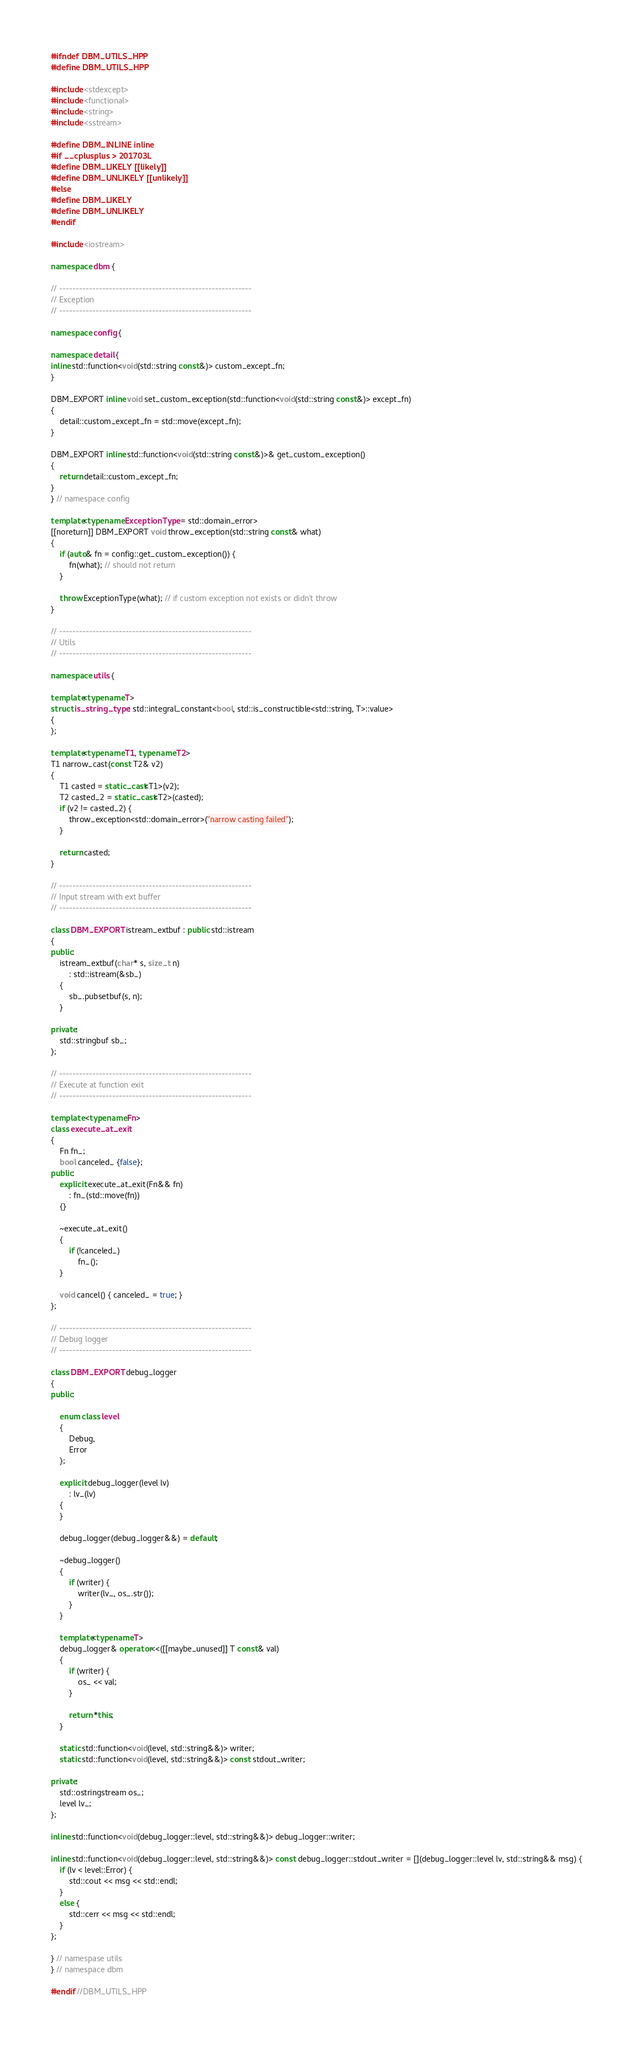<code> <loc_0><loc_0><loc_500><loc_500><_C++_>#ifndef DBM_UTILS_HPP
#define DBM_UTILS_HPP

#include <stdexcept>
#include <functional>
#include <string>
#include <sstream>

#define DBM_INLINE inline
#if __cplusplus > 201703L
#define DBM_LIKELY [[likely]]
#define DBM_UNLIKELY [[unlikely]]
#else
#define DBM_LIKELY
#define DBM_UNLIKELY
#endif

#include <iostream>

namespace dbm {

// ----------------------------------------------------------
// Exception
// ----------------------------------------------------------

namespace config {

namespace detail {
inline std::function<void(std::string const&)> custom_except_fn;
}

DBM_EXPORT inline void set_custom_exception(std::function<void(std::string const&)> except_fn)
{
    detail::custom_except_fn = std::move(except_fn);
}

DBM_EXPORT inline std::function<void(std::string const&)>& get_custom_exception()
{
    return detail::custom_except_fn;
}
} // namespace config

template<typename ExceptionType = std::domain_error>
[[noreturn]] DBM_EXPORT void throw_exception(std::string const& what)
{
    if (auto& fn = config::get_custom_exception()) {
        fn(what); // should not return
    }

    throw ExceptionType(what); // if custom exception not exists or didn't throw
}

// ----------------------------------------------------------
// Utils
// ----------------------------------------------------------

namespace utils {

template<typename T>
struct is_string_type : std::integral_constant<bool, std::is_constructible<std::string, T>::value>
{
};

template<typename T1, typename T2>
T1 narrow_cast(const T2& v2)
{
    T1 casted = static_cast<T1>(v2);
    T2 casted_2 = static_cast<T2>(casted);
    if (v2 != casted_2) {
        throw_exception<std::domain_error>("narrow casting failed");
    }

    return casted;
}

// ----------------------------------------------------------
// Input stream with ext buffer
// ----------------------------------------------------------

class DBM_EXPORT istream_extbuf : public std::istream
{
public:
    istream_extbuf(char* s, size_t n)
        : std::istream(&sb_)
    {
        sb_.pubsetbuf(s, n);
    }

private:
    std::stringbuf sb_;
};

// ----------------------------------------------------------
// Execute at function exit
// ----------------------------------------------------------

template <typename Fn>
class execute_at_exit
{
    Fn fn_;
    bool canceled_ {false};
public:
    explicit execute_at_exit(Fn&& fn)
        : fn_(std::move(fn))
    {}

    ~execute_at_exit()
    {
        if (!canceled_)
            fn_();
    }

    void cancel() { canceled_ = true; }
};

// ----------------------------------------------------------
// Debug logger
// ----------------------------------------------------------

class DBM_EXPORT debug_logger
{
public:

    enum class level
    {
        Debug,
        Error
    };

    explicit debug_logger(level lv)
        : lv_(lv)
    {
    }

    debug_logger(debug_logger&&) = default;

    ~debug_logger()
    {
        if (writer) {
            writer(lv_, os_.str());
        }
    }

    template<typename T>
    debug_logger& operator<<([[maybe_unused]] T const& val)
    {
        if (writer) {
            os_ << val;
        }

        return *this;
    }

    static std::function<void(level, std::string&&)> writer;
    static std::function<void(level, std::string&&)> const stdout_writer;

private:
    std::ostringstream os_;
    level lv_;
};

inline std::function<void(debug_logger::level, std::string&&)> debug_logger::writer;

inline std::function<void(debug_logger::level, std::string&&)> const debug_logger::stdout_writer = [](debug_logger::level lv, std::string&& msg) {
    if (lv < level::Error) {
        std::cout << msg << std::endl;
    }
    else {
        std::cerr << msg << std::endl;
    }
};

} // namespase utils
} // namespace dbm

#endif //DBM_UTILS_HPP
</code> 